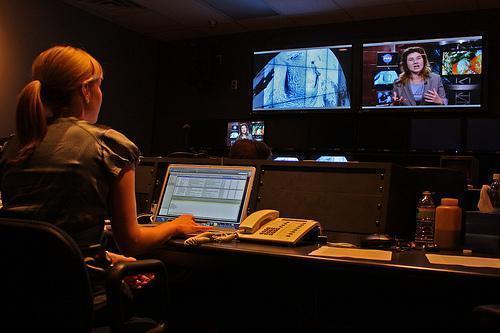How many women watching the TV?
Give a very brief answer. 1. 